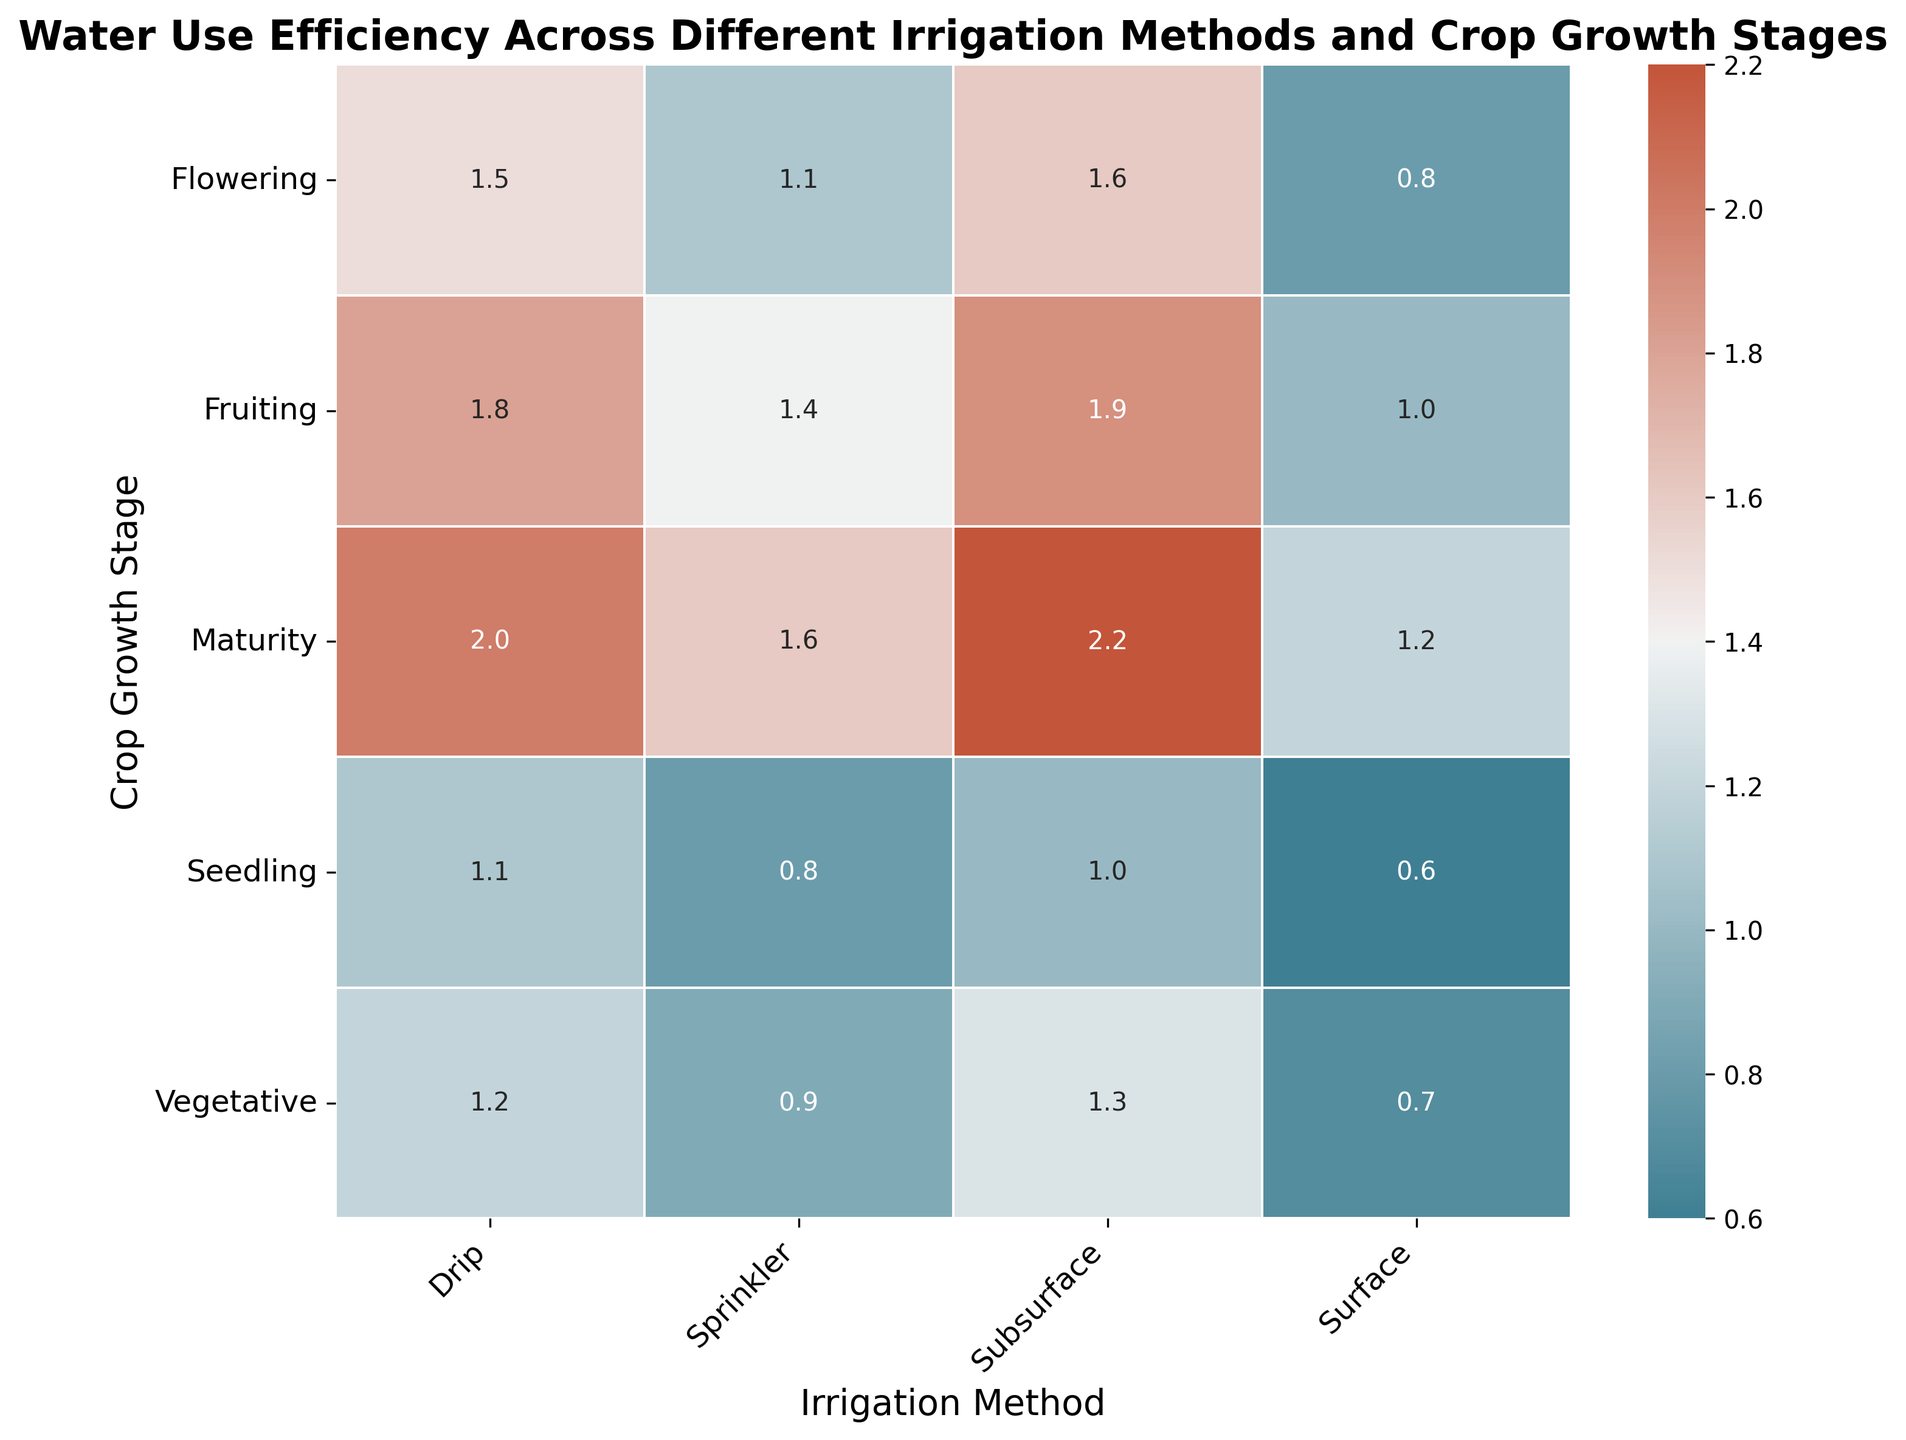Which irrigation method has the highest water use efficiency at the maturity stage? At the maturity stage, locate the highest value among the different irrigation methods. Subsurface shows a value of 2.2, which is the highest.
Answer: Subsurface How does water use efficiency change from vegetative to fruiting stages for the drip method? For the drip method, check the values for vegetative, flowering, and fruiting stages. The values are 1.2, 1.5, and 1.8 respectively, indicating an increasing trend.
Answer: Increasing Compare the water use efficiency between drip and sprinkler methods during the flowering stage. Look at the flowering stage values for drip and sprinkler methods. Drip has 1.5, and sprinkler has 1.1. Drip is higher.
Answer: Drip What is the average water use efficiency during the seedling stage across all irrigation methods? Add the values for each irrigation method at the seedling stage, then divide by the number of methods: (1.1 + 0.8 + 0.6 + 1.0) / 4 = 3.5 / 4 = 0.875.
Answer: 0.875 Which crop growth stage shows the lowest water use efficiency for surface irrigation? Identify the lowest value among all stages for surface irrigation. For surface, the values are 0.7 (vegetative), 0.8 (flowering), 1.0 (fruiting), 0.6 (seedling), and 1.2 (maturity). Seedling stage has the lowest value at 0.6.
Answer: Seedling Is the water use efficiency higher for subsurface than surface irrigation during the vegetative stage? Compare the values for subsurface and surface irrigation during the vegetative stage. Subsurface has 1.3, while surface has 0.7, so subsurface is higher.
Answer: Yes What is the difference in water use efficiency between drip and subsurface methods at the fruiting stage? Subtract the value of subsurface from the drip at the fruiting stage. The values are 1.8 (drip) and 1.9 (subsurface), so the difference is 1.9 - 1.8 = 0.1.
Answer: 0.1 In which crop growth stage does the sprinkler method show the highest water use efficiency? Find the highest value for the sprinkler method across all stages. The values are 0.9 (vegetative), 1.1 (flowering), 1.4 (fruiting), 0.8 (seedling), 1.6 (maturity). The highest value is 1.6 at the maturity stage.
Answer: Maturity Calculate the sum of water use efficiencies for surface irrigation across all crop growth stages. Add the values for surface irrigation at each stage. The values are 0.7 (vegetative), 0.8 (flowering), 1.0 (fruiting), 0.6 (seedling), 1.2 (maturity). The sum is 0.7 + 0.8 + 1.0 + 0.6 + 1.2 = 4.3.
Answer: 4.3 